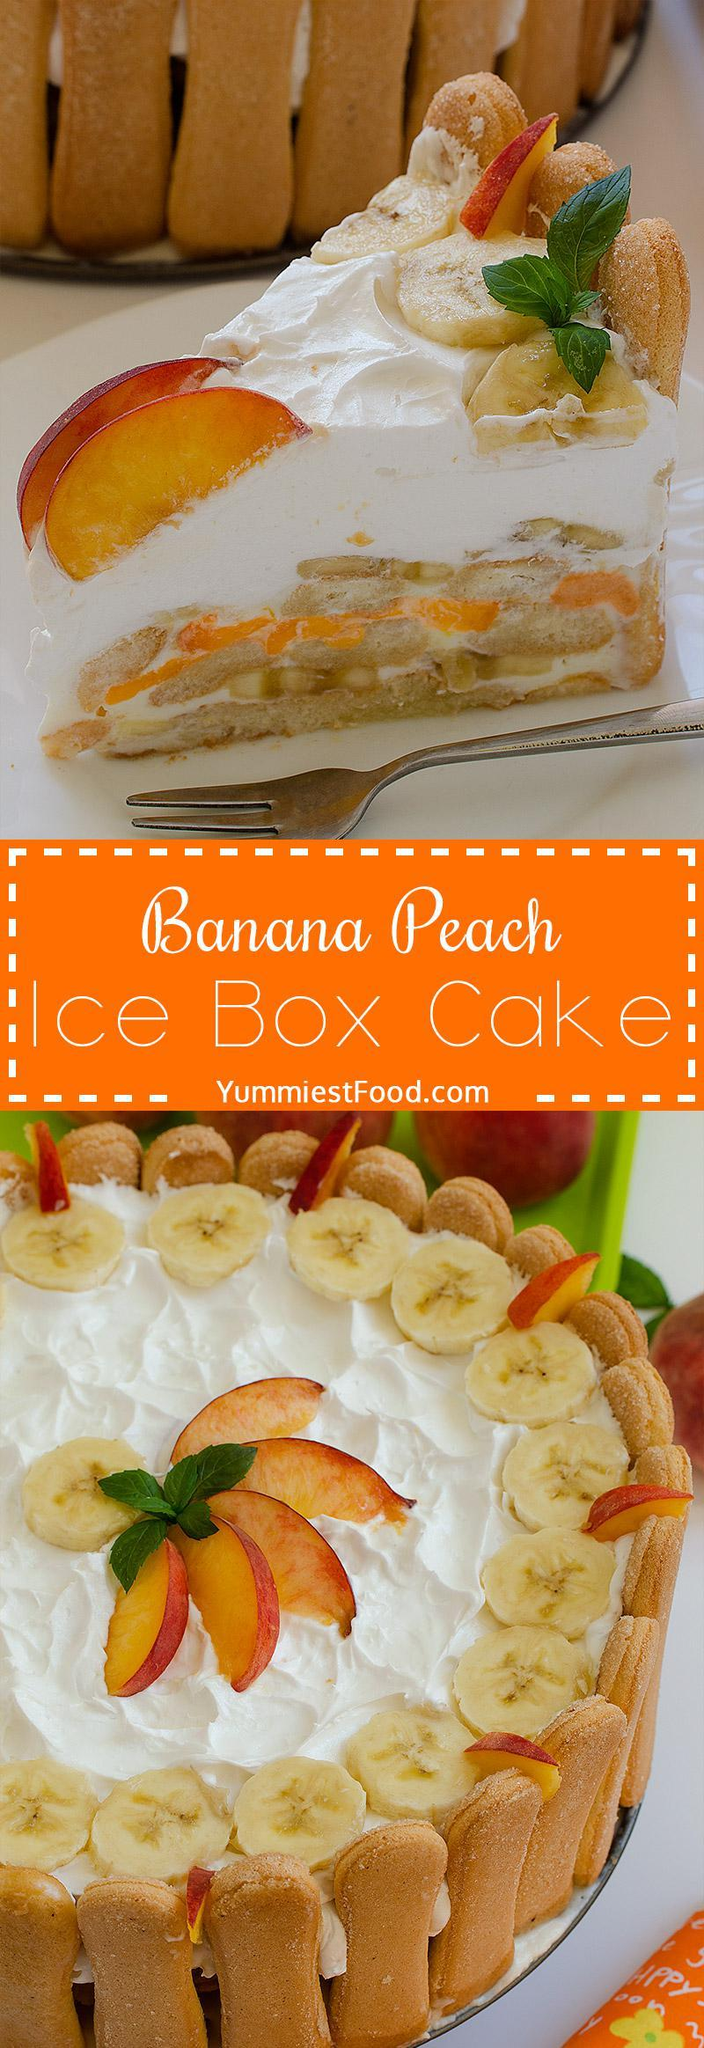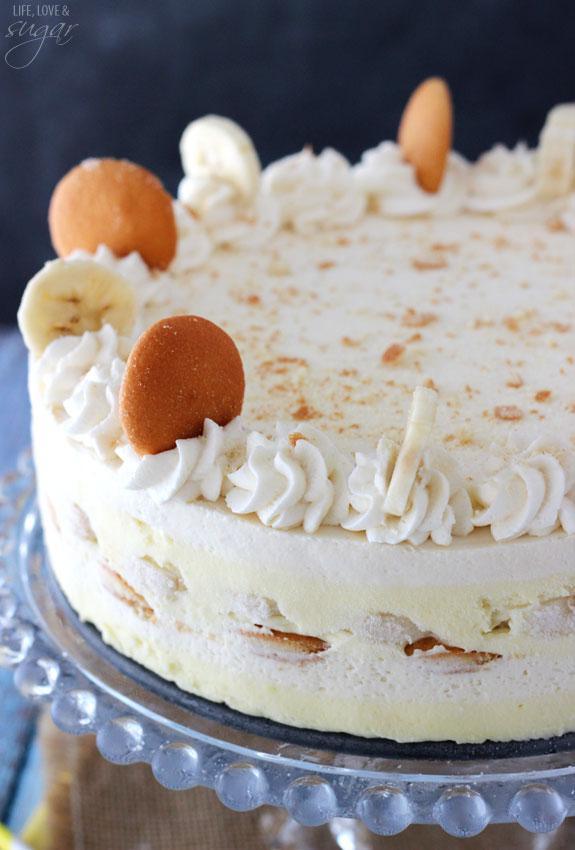The first image is the image on the left, the second image is the image on the right. For the images displayed, is the sentence "there is a cake with beaches on top and lady finger cookies around the outside" factually correct? Answer yes or no. Yes. The first image is the image on the left, the second image is the image on the right. For the images displayed, is the sentence "One image shows a plate of sliced desserts in front of an uncut loaf and next to a knife." factually correct? Answer yes or no. No. 